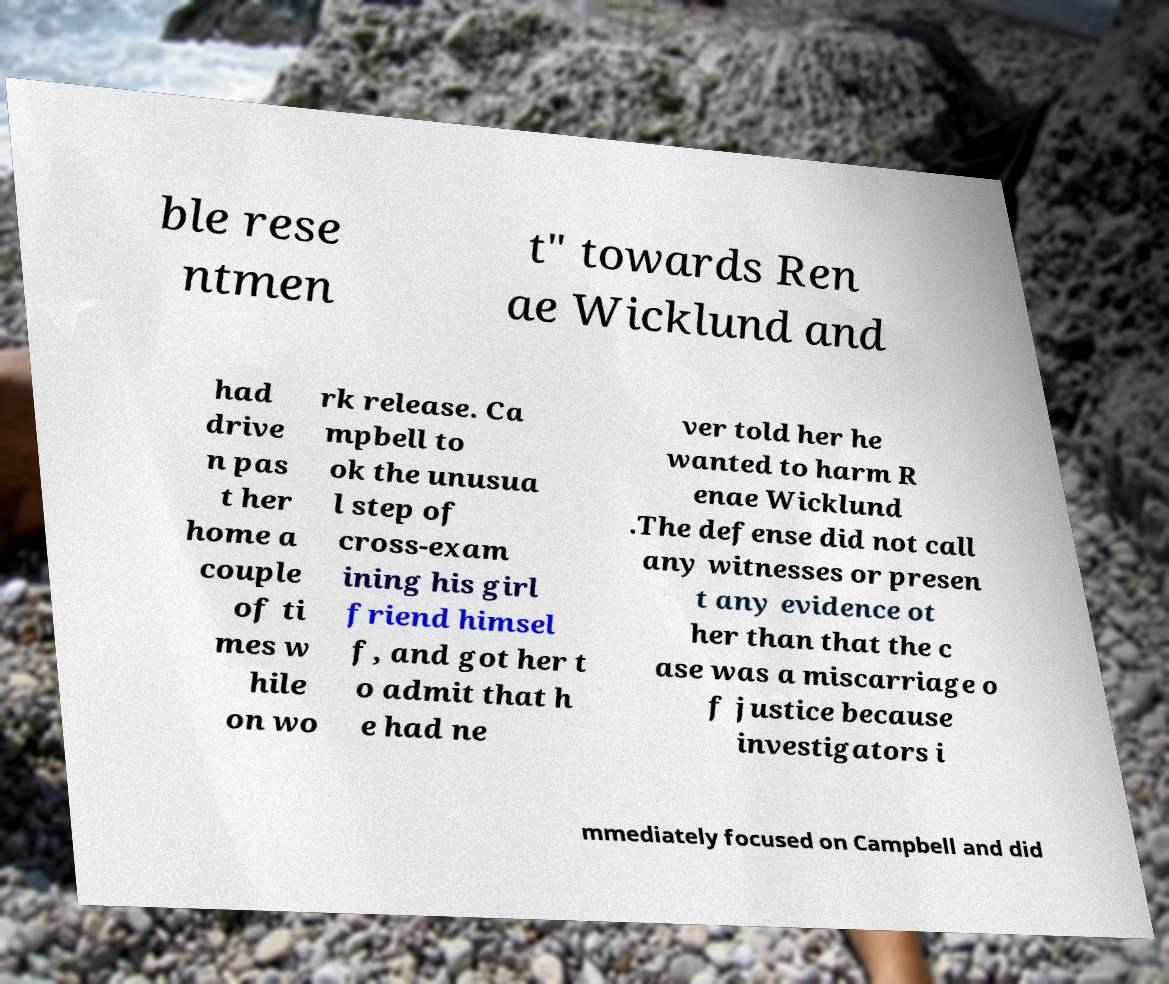What messages or text are displayed in this image? I need them in a readable, typed format. ble rese ntmen t" towards Ren ae Wicklund and had drive n pas t her home a couple of ti mes w hile on wo rk release. Ca mpbell to ok the unusua l step of cross-exam ining his girl friend himsel f, and got her t o admit that h e had ne ver told her he wanted to harm R enae Wicklund .The defense did not call any witnesses or presen t any evidence ot her than that the c ase was a miscarriage o f justice because investigators i mmediately focused on Campbell and did 